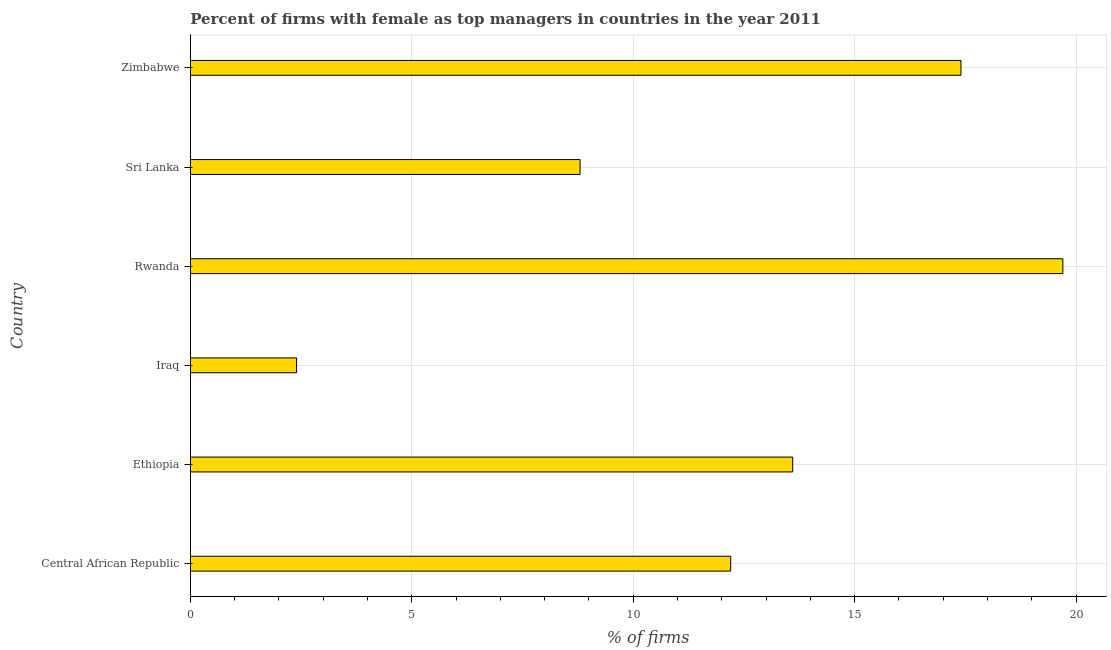What is the title of the graph?
Provide a succinct answer. Percent of firms with female as top managers in countries in the year 2011. What is the label or title of the X-axis?
Make the answer very short. % of firms. What is the percentage of firms with female as top manager in Zimbabwe?
Make the answer very short. 17.4. In which country was the percentage of firms with female as top manager maximum?
Your response must be concise. Rwanda. In which country was the percentage of firms with female as top manager minimum?
Provide a succinct answer. Iraq. What is the sum of the percentage of firms with female as top manager?
Keep it short and to the point. 74.1. What is the difference between the percentage of firms with female as top manager in Iraq and Rwanda?
Your response must be concise. -17.3. What is the average percentage of firms with female as top manager per country?
Your answer should be compact. 12.35. What is the median percentage of firms with female as top manager?
Offer a terse response. 12.9. What is the ratio of the percentage of firms with female as top manager in Iraq to that in Sri Lanka?
Give a very brief answer. 0.27. Is the percentage of firms with female as top manager in Central African Republic less than that in Rwanda?
Make the answer very short. Yes. Is the difference between the percentage of firms with female as top manager in Sri Lanka and Zimbabwe greater than the difference between any two countries?
Your answer should be very brief. No. What is the difference between the highest and the second highest percentage of firms with female as top manager?
Provide a short and direct response. 2.3. Is the sum of the percentage of firms with female as top manager in Central African Republic and Rwanda greater than the maximum percentage of firms with female as top manager across all countries?
Ensure brevity in your answer.  Yes. In how many countries, is the percentage of firms with female as top manager greater than the average percentage of firms with female as top manager taken over all countries?
Your response must be concise. 3. How many bars are there?
Keep it short and to the point. 6. Are all the bars in the graph horizontal?
Provide a succinct answer. Yes. What is the difference between two consecutive major ticks on the X-axis?
Your response must be concise. 5. What is the % of firms of Iraq?
Make the answer very short. 2.4. What is the % of firms in Rwanda?
Offer a terse response. 19.7. What is the % of firms in Sri Lanka?
Your answer should be compact. 8.8. What is the % of firms in Zimbabwe?
Your answer should be very brief. 17.4. What is the difference between the % of firms in Central African Republic and Ethiopia?
Keep it short and to the point. -1.4. What is the difference between the % of firms in Central African Republic and Iraq?
Your answer should be compact. 9.8. What is the difference between the % of firms in Central African Republic and Rwanda?
Ensure brevity in your answer.  -7.5. What is the difference between the % of firms in Central African Republic and Sri Lanka?
Your answer should be very brief. 3.4. What is the difference between the % of firms in Central African Republic and Zimbabwe?
Your response must be concise. -5.2. What is the difference between the % of firms in Ethiopia and Iraq?
Give a very brief answer. 11.2. What is the difference between the % of firms in Ethiopia and Sri Lanka?
Your answer should be compact. 4.8. What is the difference between the % of firms in Ethiopia and Zimbabwe?
Your response must be concise. -3.8. What is the difference between the % of firms in Iraq and Rwanda?
Your response must be concise. -17.3. What is the difference between the % of firms in Iraq and Sri Lanka?
Give a very brief answer. -6.4. What is the difference between the % of firms in Sri Lanka and Zimbabwe?
Provide a short and direct response. -8.6. What is the ratio of the % of firms in Central African Republic to that in Ethiopia?
Offer a very short reply. 0.9. What is the ratio of the % of firms in Central African Republic to that in Iraq?
Your answer should be very brief. 5.08. What is the ratio of the % of firms in Central African Republic to that in Rwanda?
Ensure brevity in your answer.  0.62. What is the ratio of the % of firms in Central African Republic to that in Sri Lanka?
Offer a very short reply. 1.39. What is the ratio of the % of firms in Central African Republic to that in Zimbabwe?
Make the answer very short. 0.7. What is the ratio of the % of firms in Ethiopia to that in Iraq?
Give a very brief answer. 5.67. What is the ratio of the % of firms in Ethiopia to that in Rwanda?
Provide a succinct answer. 0.69. What is the ratio of the % of firms in Ethiopia to that in Sri Lanka?
Your response must be concise. 1.54. What is the ratio of the % of firms in Ethiopia to that in Zimbabwe?
Keep it short and to the point. 0.78. What is the ratio of the % of firms in Iraq to that in Rwanda?
Keep it short and to the point. 0.12. What is the ratio of the % of firms in Iraq to that in Sri Lanka?
Your answer should be very brief. 0.27. What is the ratio of the % of firms in Iraq to that in Zimbabwe?
Keep it short and to the point. 0.14. What is the ratio of the % of firms in Rwanda to that in Sri Lanka?
Offer a terse response. 2.24. What is the ratio of the % of firms in Rwanda to that in Zimbabwe?
Your answer should be compact. 1.13. What is the ratio of the % of firms in Sri Lanka to that in Zimbabwe?
Your answer should be very brief. 0.51. 